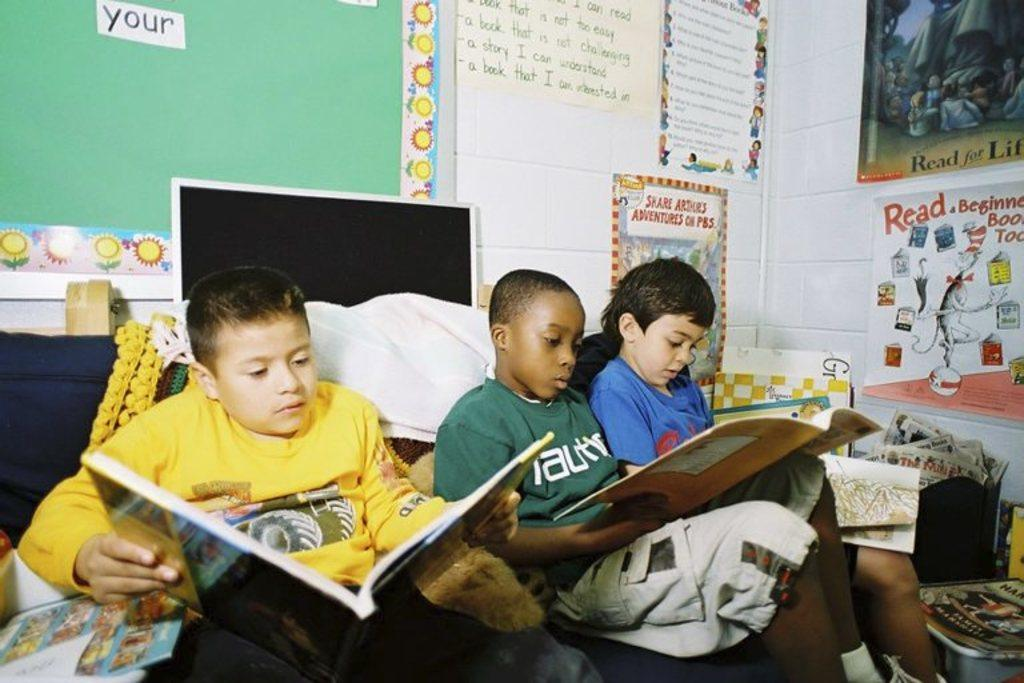<image>
Summarize the visual content of the image. Children reading in front of a board that says "share adventures". 